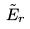<formula> <loc_0><loc_0><loc_500><loc_500>\tilde { E } _ { r }</formula> 